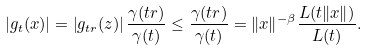<formula> <loc_0><loc_0><loc_500><loc_500>\left | g _ { t } ( x ) \right | = \left | g _ { t r } ( z ) \right | \frac { \gamma ( t r ) } { \gamma ( t ) } \leq \frac { \gamma ( t r ) } { \gamma ( t ) } = \| x \| ^ { - \beta } \frac { L ( t \| x \| ) } { L ( t ) } .</formula> 